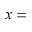<formula> <loc_0><loc_0><loc_500><loc_500>x =</formula> 